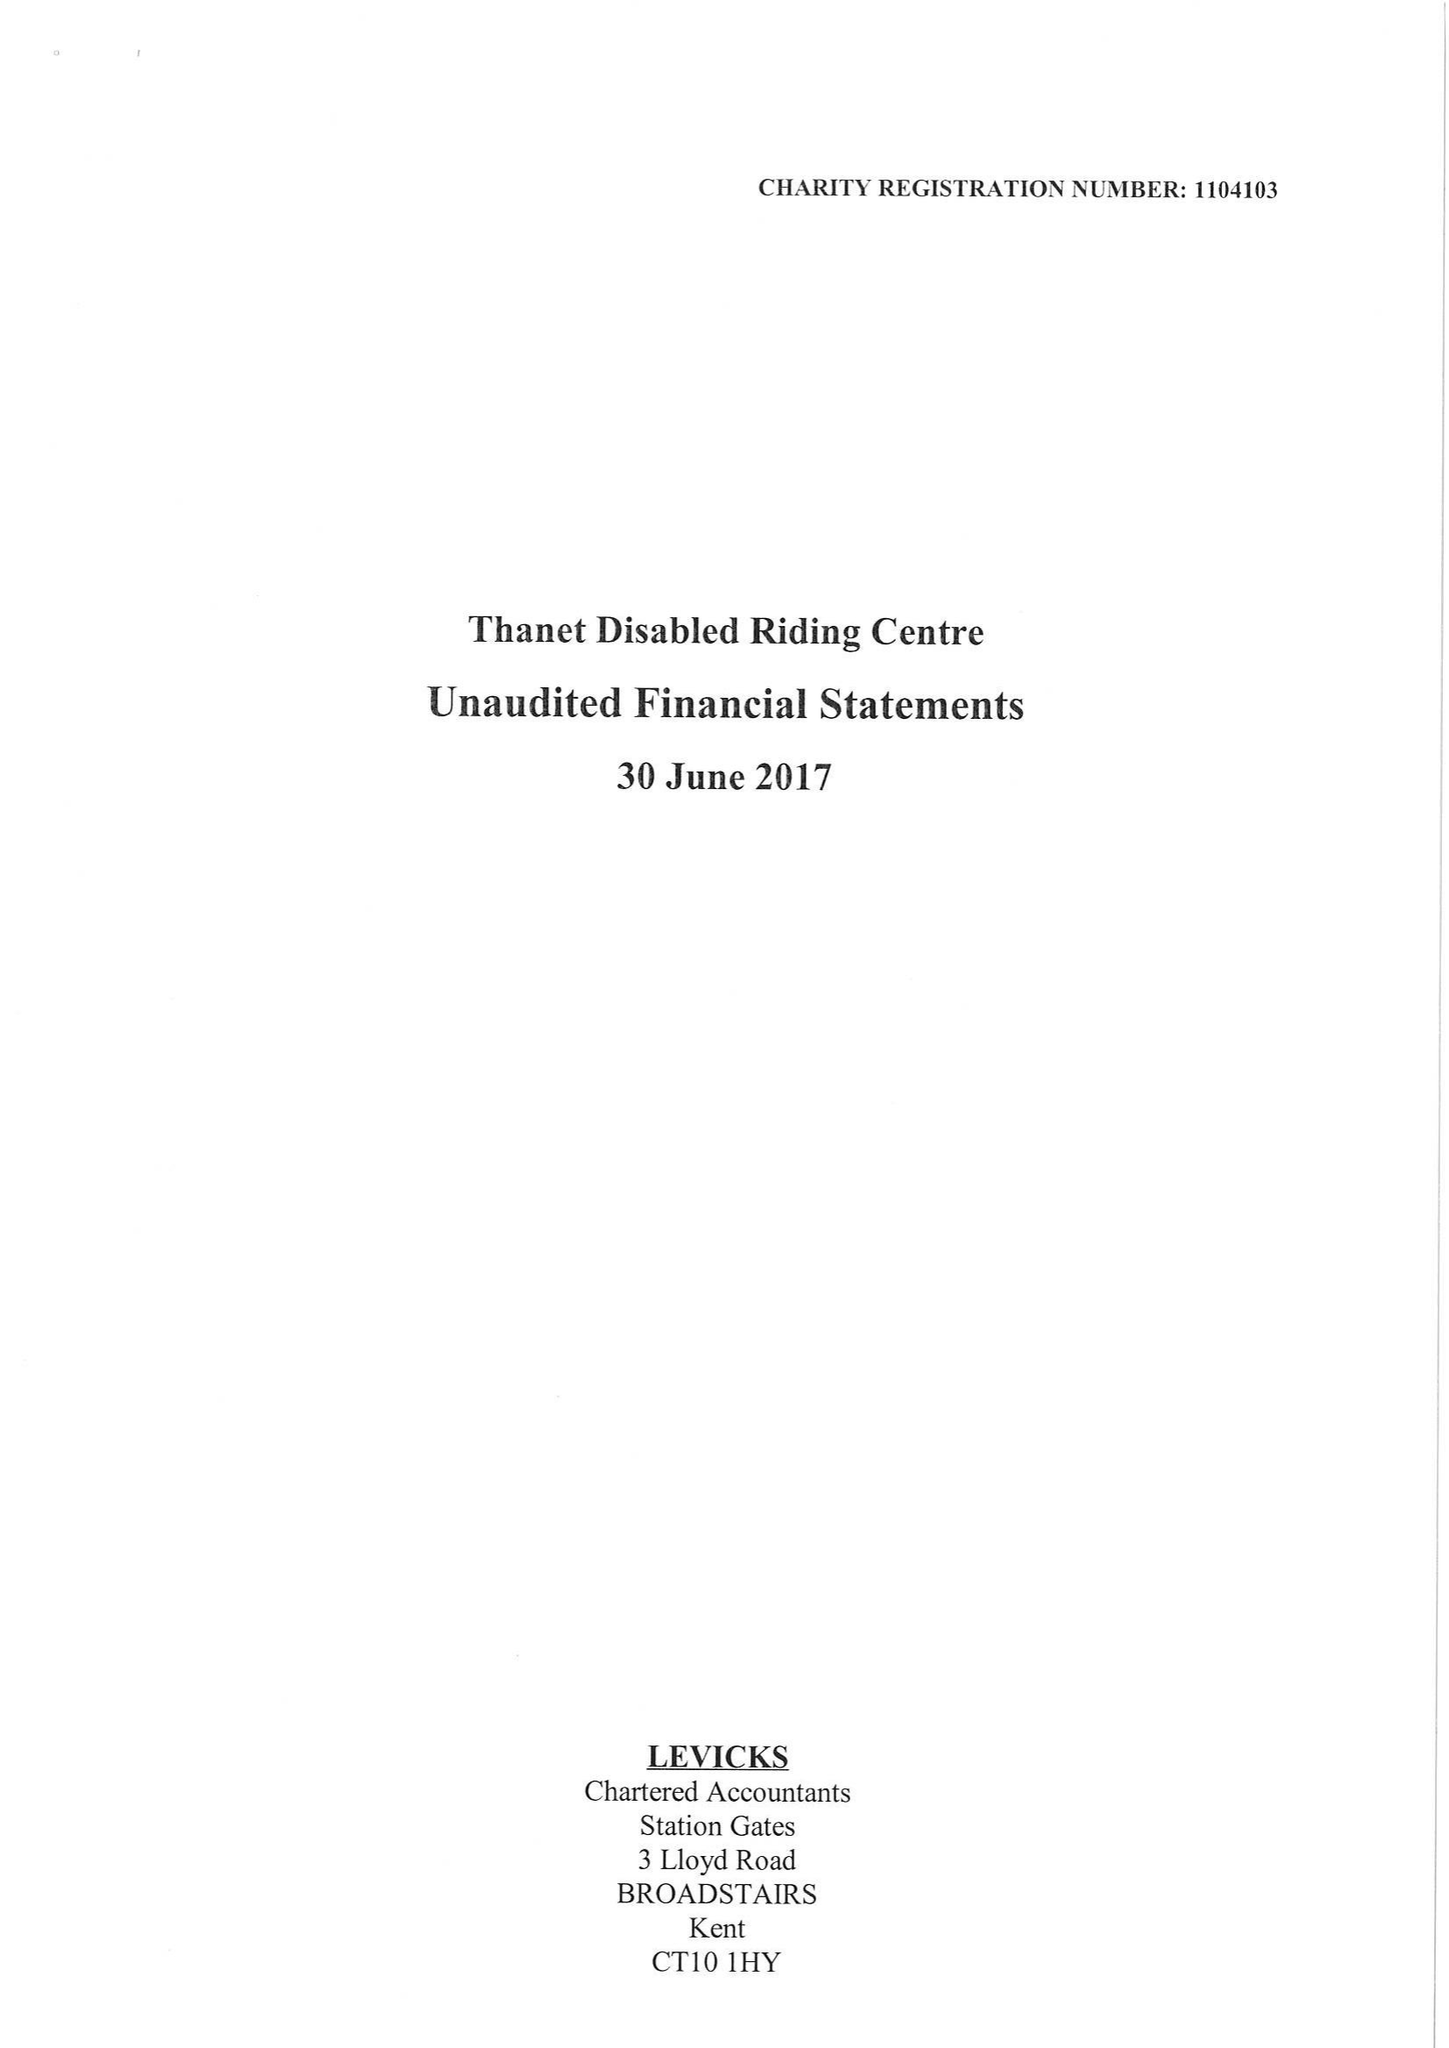What is the value for the report_date?
Answer the question using a single word or phrase. 2017-06-30 